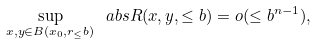Convert formula to latex. <formula><loc_0><loc_0><loc_500><loc_500>\sup _ { x , y \in B ( x _ { 0 } , r _ { \leq } b ) } \ a b s { R ( x , y , \leq b ) } = o ( \leq b ^ { n - 1 } ) ,</formula> 